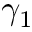Convert formula to latex. <formula><loc_0><loc_0><loc_500><loc_500>\gamma _ { 1 }</formula> 